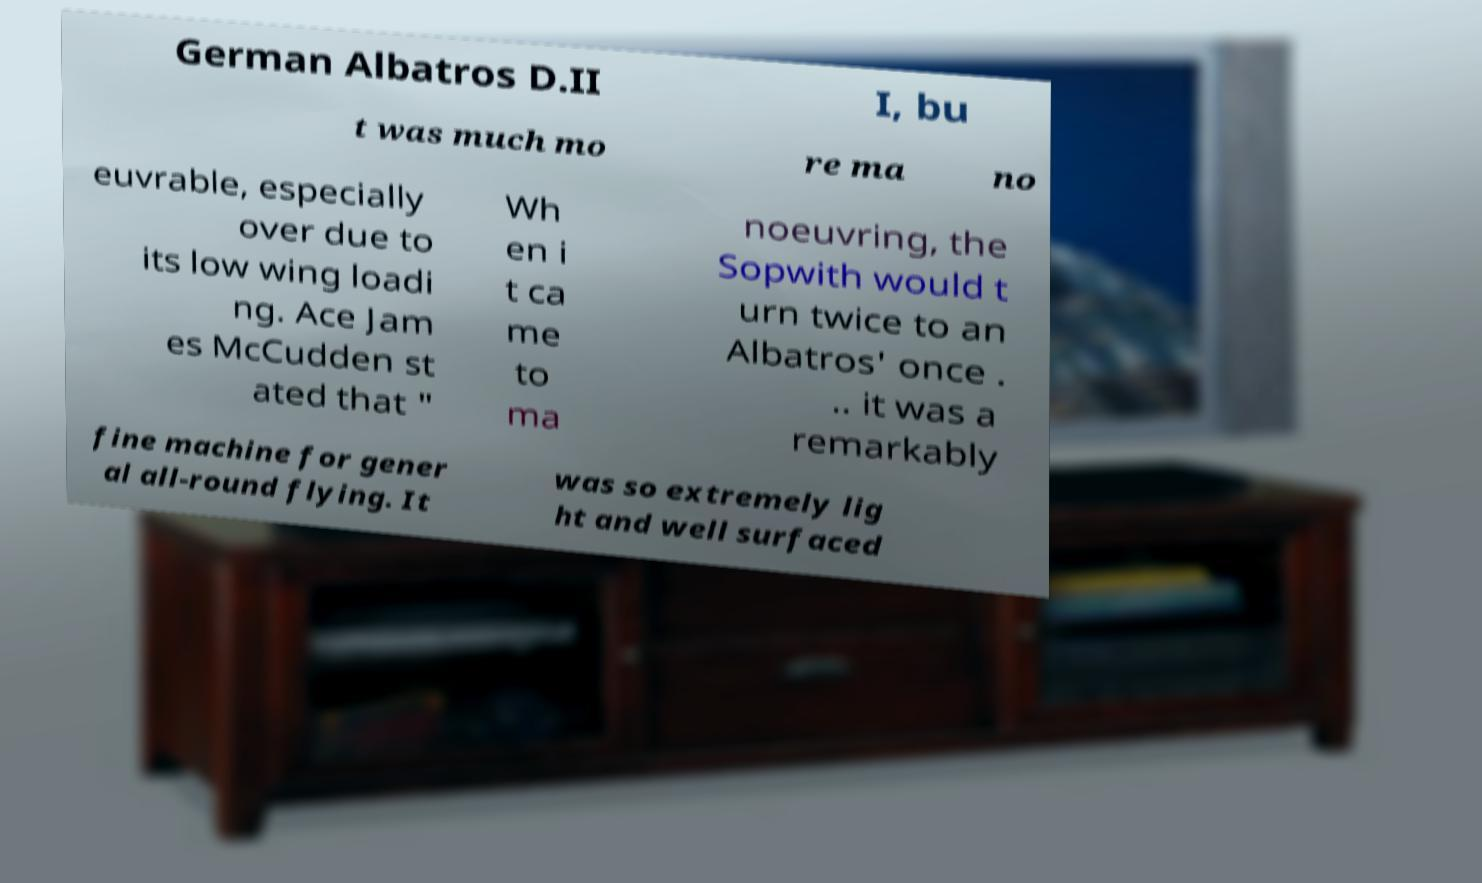Can you read and provide the text displayed in the image?This photo seems to have some interesting text. Can you extract and type it out for me? German Albatros D.II I, bu t was much mo re ma no euvrable, especially over due to its low wing loadi ng. Ace Jam es McCudden st ated that " Wh en i t ca me to ma noeuvring, the Sopwith would t urn twice to an Albatros' once . .. it was a remarkably fine machine for gener al all-round flying. It was so extremely lig ht and well surfaced 